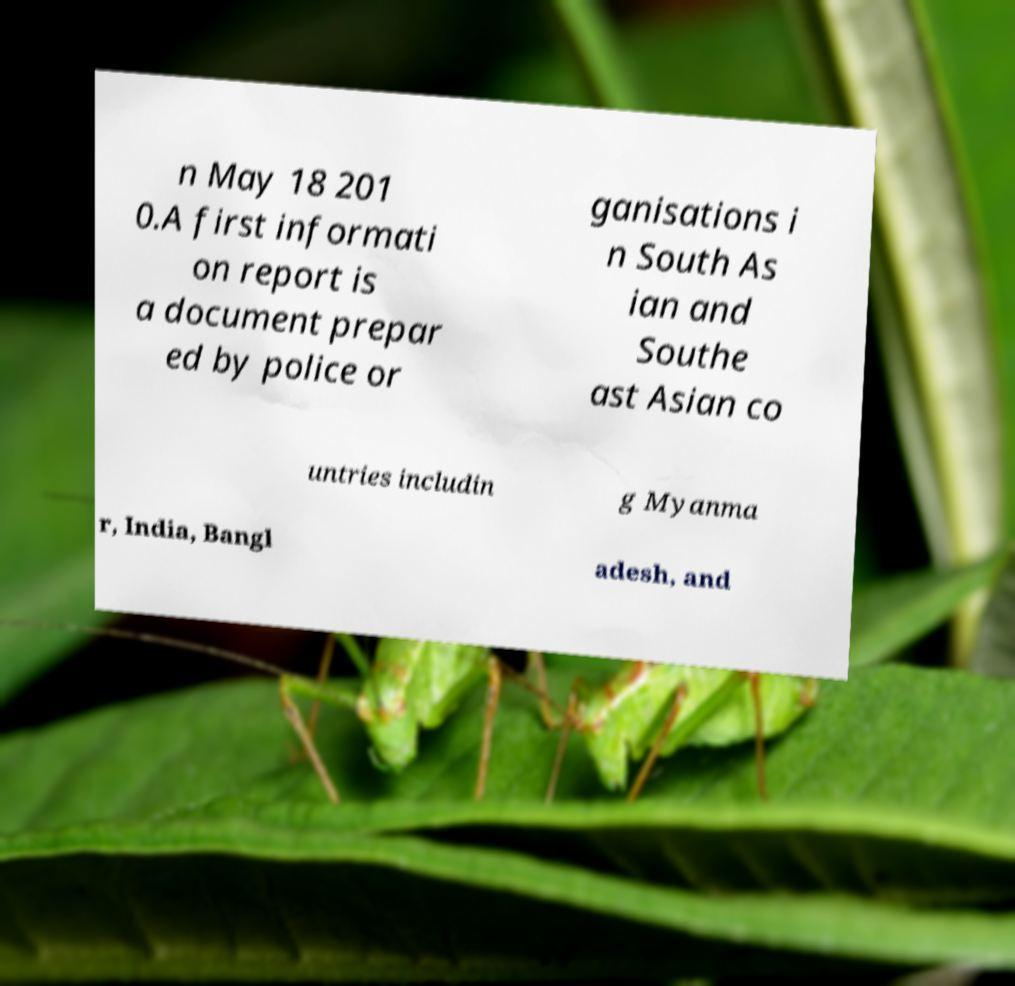Could you assist in decoding the text presented in this image and type it out clearly? n May 18 201 0.A first informati on report is a document prepar ed by police or ganisations i n South As ian and Southe ast Asian co untries includin g Myanma r, India, Bangl adesh, and 